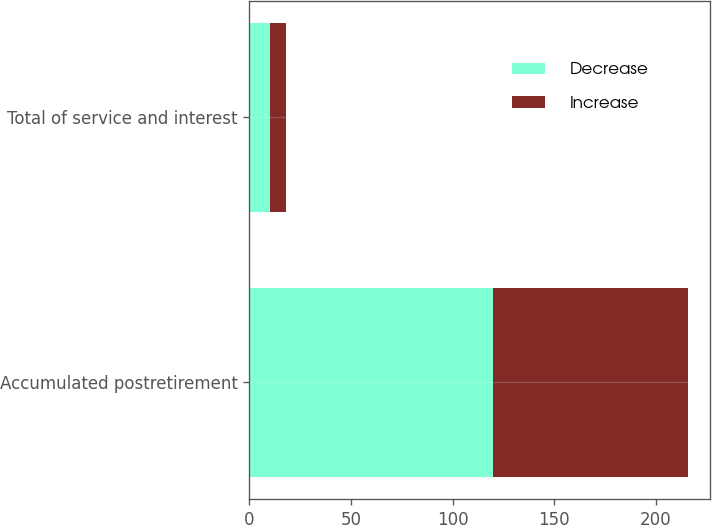Convert chart. <chart><loc_0><loc_0><loc_500><loc_500><stacked_bar_chart><ecel><fcel>Accumulated postretirement<fcel>Total of service and interest<nl><fcel>Decrease<fcel>120<fcel>10<nl><fcel>Increase<fcel>96<fcel>8<nl></chart> 